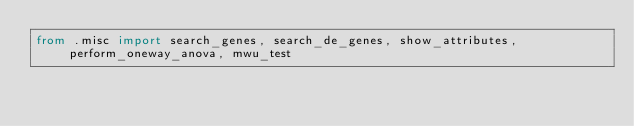<code> <loc_0><loc_0><loc_500><loc_500><_Python_>from .misc import search_genes, search_de_genes, show_attributes, perform_oneway_anova, mwu_test
</code> 